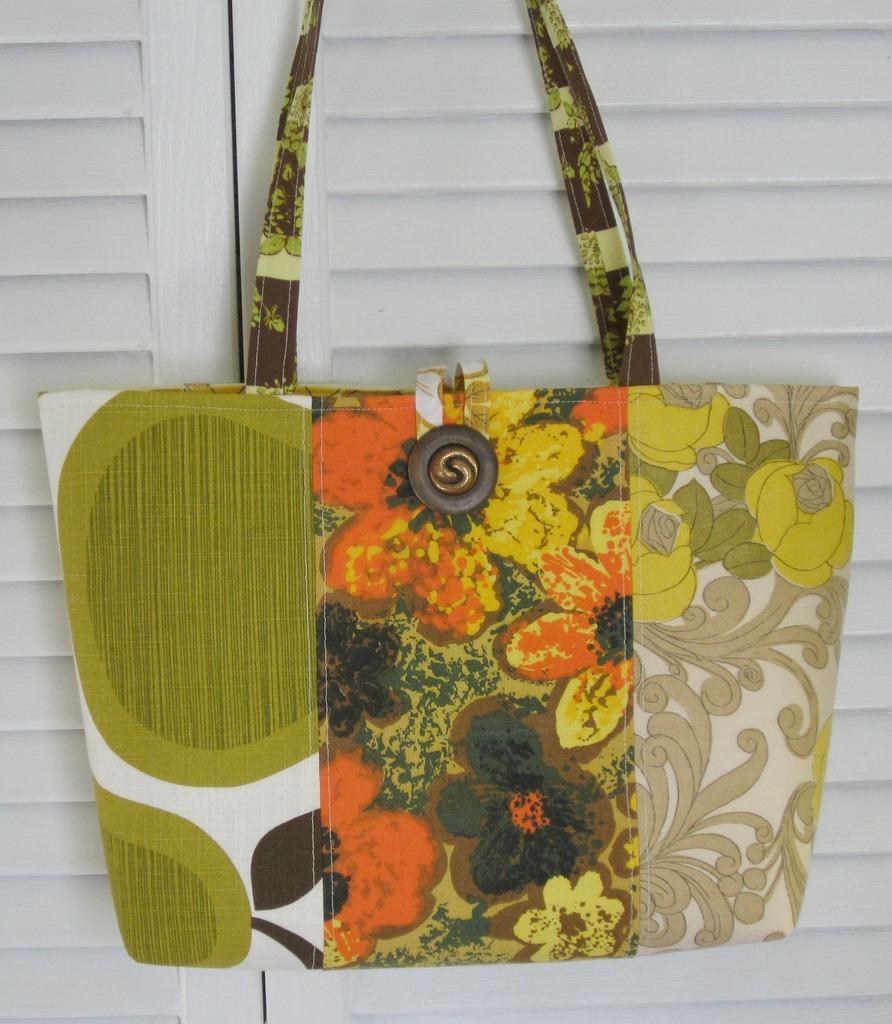Could you give a brief overview of what you see in this image? a bag is hung. at its center there are flowers. 